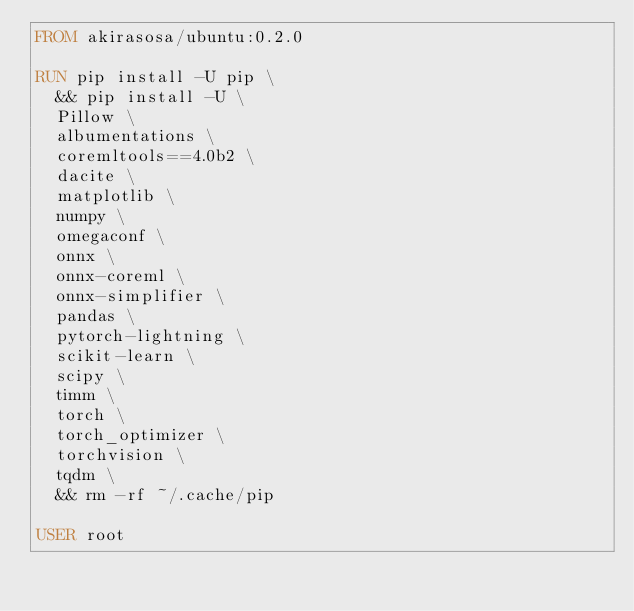Convert code to text. <code><loc_0><loc_0><loc_500><loc_500><_Dockerfile_>FROM akirasosa/ubuntu:0.2.0

RUN pip install -U pip \
  && pip install -U \
  Pillow \
  albumentations \
  coremltools==4.0b2 \
  dacite \
  matplotlib \
  numpy \
  omegaconf \
  onnx \
  onnx-coreml \
  onnx-simplifier \
  pandas \
  pytorch-lightning \
  scikit-learn \
  scipy \
  timm \
  torch \
  torch_optimizer \
  torchvision \
  tqdm \
  && rm -rf ~/.cache/pip

USER root

</code> 